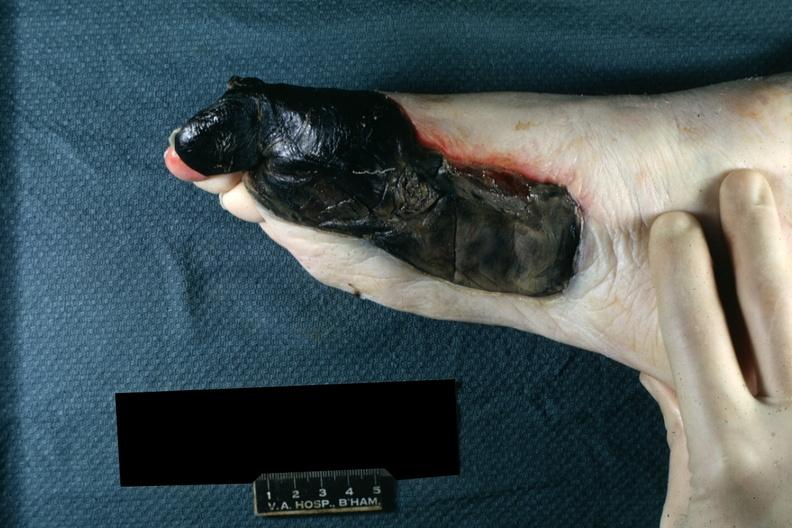s medial aspect left foot?
Answer the question using a single word or phrase. Yes 